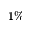<formula> <loc_0><loc_0><loc_500><loc_500>1 \%</formula> 